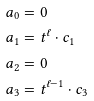<formula> <loc_0><loc_0><loc_500><loc_500>\ a _ { 0 } & = 0 \\ \ a _ { 1 } & = t ^ { \ell } \cdot c _ { 1 } \\ \ a _ { 2 } & = 0 \\ \ a _ { 3 } & = t ^ { \ell - 1 } \cdot c _ { 3 }</formula> 